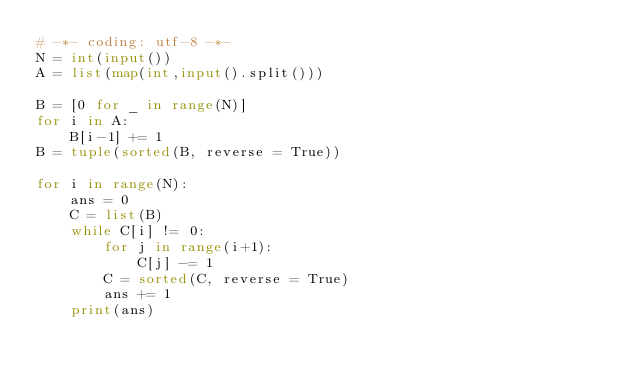Convert code to text. <code><loc_0><loc_0><loc_500><loc_500><_Python_># -*- coding: utf-8 -*-
N = int(input())
A = list(map(int,input().split()))

B = [0 for _ in range(N)]
for i in A:
    B[i-1] += 1
B = tuple(sorted(B, reverse = True))

for i in range(N):
    ans = 0
    C = list(B)
    while C[i] != 0:
        for j in range(i+1):
            C[j] -= 1
        C = sorted(C, reverse = True)
        ans += 1
    print(ans)</code> 